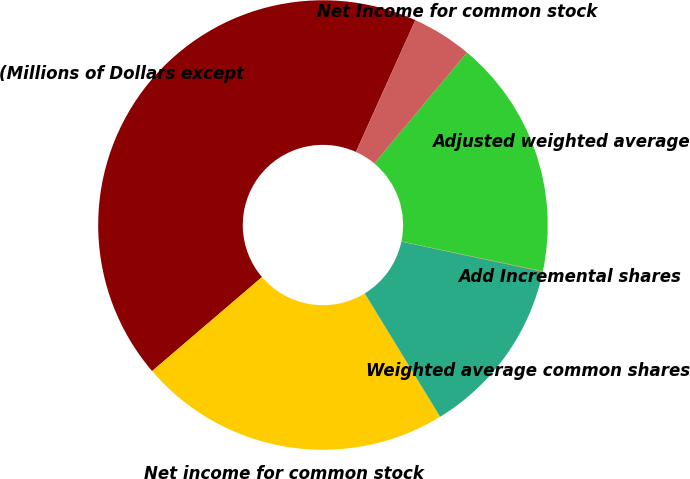<chart> <loc_0><loc_0><loc_500><loc_500><pie_chart><fcel>(Millions of Dollars except<fcel>Net income for common stock<fcel>Weighted average common shares<fcel>Add Incremental shares<fcel>Adjusted weighted average<fcel>Net Income for common stock<nl><fcel>43.0%<fcel>22.47%<fcel>12.93%<fcel>0.04%<fcel>17.22%<fcel>4.33%<nl></chart> 